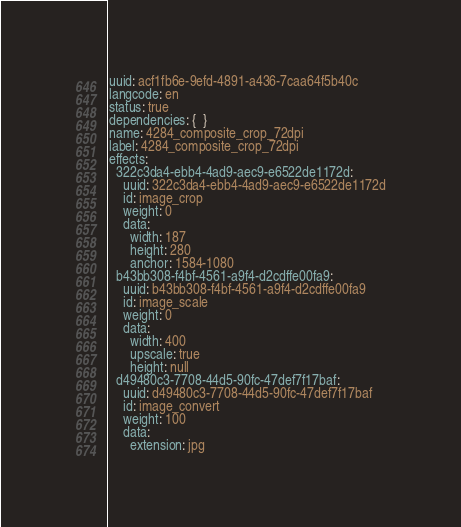Convert code to text. <code><loc_0><loc_0><loc_500><loc_500><_YAML_>uuid: acf1fb6e-9efd-4891-a436-7caa64f5b40c
langcode: en
status: true
dependencies: {  }
name: 4284_composite_crop_72dpi
label: 4284_composite_crop_72dpi
effects:
  322c3da4-ebb4-4ad9-aec9-e6522de1172d:
    uuid: 322c3da4-ebb4-4ad9-aec9-e6522de1172d
    id: image_crop
    weight: 0
    data:
      width: 187
      height: 280
      anchor: 1584-1080
  b43bb308-f4bf-4561-a9f4-d2cdffe00fa9:
    uuid: b43bb308-f4bf-4561-a9f4-d2cdffe00fa9
    id: image_scale
    weight: 0
    data:
      width: 400
      upscale: true
      height: null
  d49480c3-7708-44d5-90fc-47def7f17baf:
    uuid: d49480c3-7708-44d5-90fc-47def7f17baf
    id: image_convert
    weight: 100
    data:
      extension: jpg
</code> 